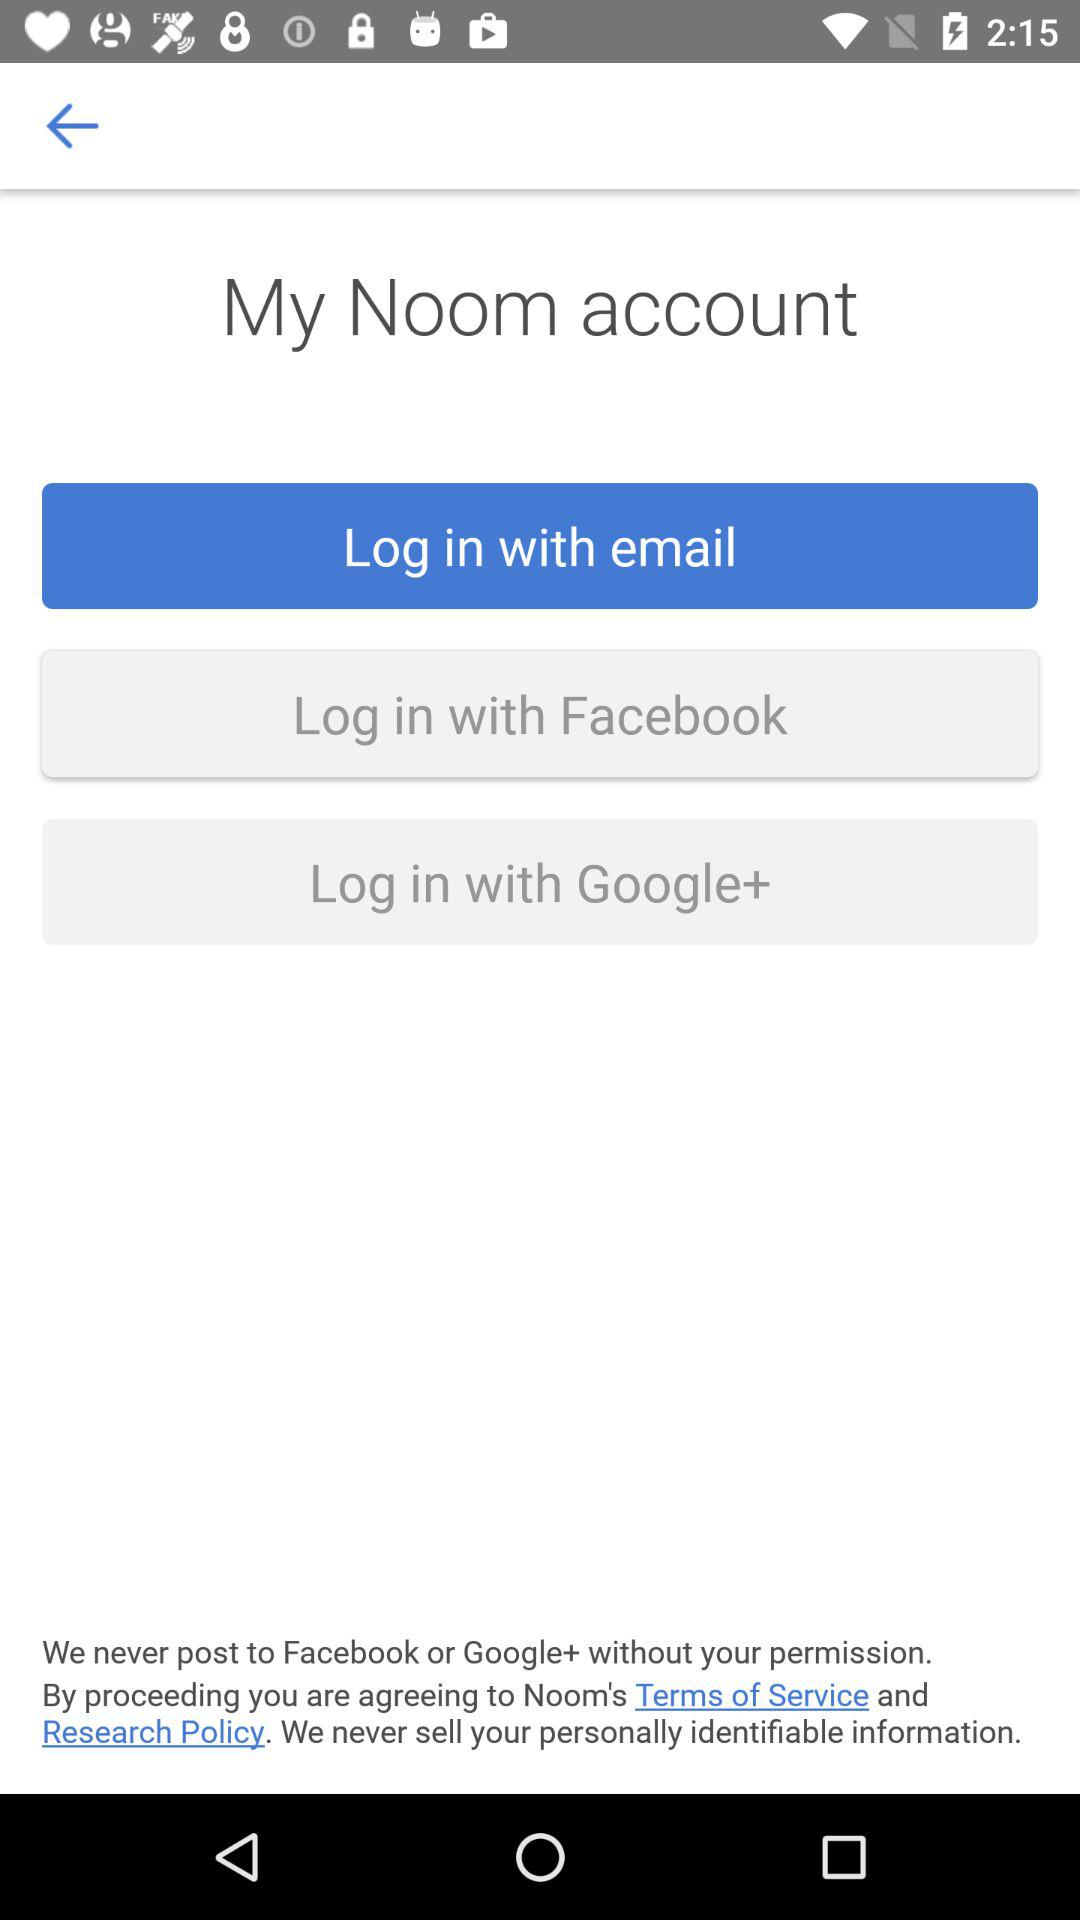What are the different options available for logging in? The different options are "email", "Facebook" and "Google+". 